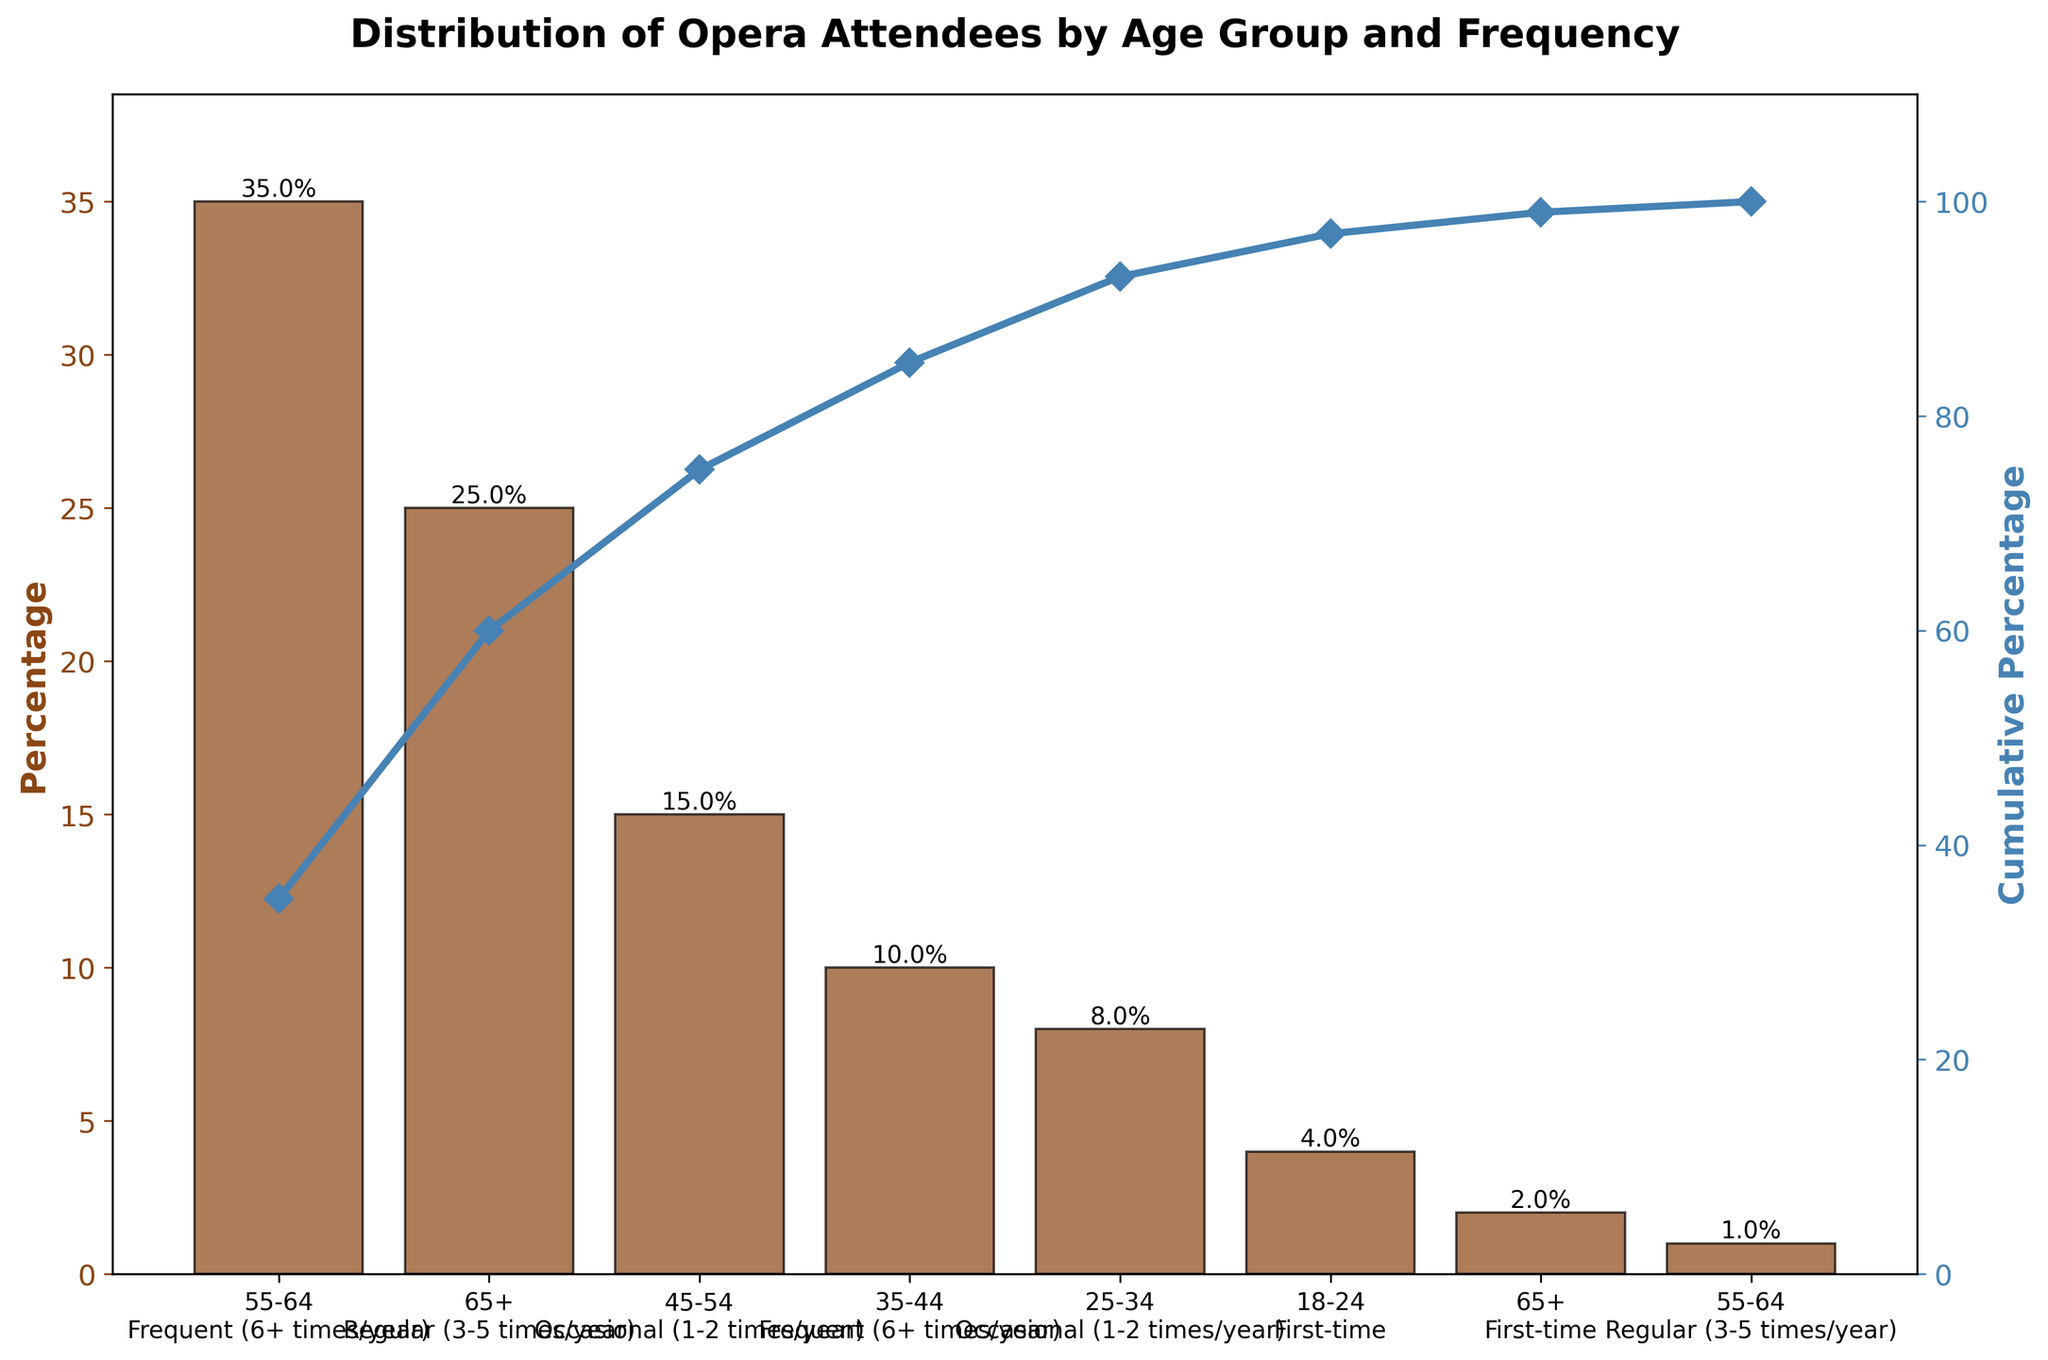What is the age group and frequency with the highest percentage of opera attendees? The figure indicates that the age group 55-64 who attend frequently (6+ times/year) has the highest percentage, as represented by the tallest bar on the chart.
Answer: 55-64, Frequent (6+ times/year) Which age group and frequency has the lowest percentage of opera attendees? The figure shows that the age group 55-64 who attend regularly (3-5 times/year) has the lowest percentage, represented by the shortest bar on the chart.
Answer: 55-64, Regular (3-5 times/year) What is the cumulative percentage after the second data point? The cumulative percentage is obtained by adding the percentages of the first two data points. The first one is 35% and the second one is 25%, so the cumulative percentage is 35% + 25% = 60%.
Answer: 60% How many age group and frequency combinations have a percentage higher than 20%? According to the chart, there are two combinations with a percentage higher than 20%. They are "55-64, Frequent (6+ times/year)" at 35% and "65+, Regular (3-5 times/year)" at 25%.
Answer: 2 Which age group and frequency combination contributes to 75% of the cumulative percentage? We need to add up the percentages until we reach or exceed 75%. From the chart, 55-64 Frequent (6+ times/year) = 35%, plus 65+ Regular (3-5 times/year) = 25% gives us 60%, and adding 45-54 Occasional (1-2 times/year) = 15% gives a total of 75%. So, up until the third combination, we reach 75%.
Answer: 45-54, Occasional (1-2 times/year) How does the cumulative percentage trend change after adding the age group 35-44 who attend frequently? The cumulative percentage after the third data point is 60%, after the fourth data point, which is 35-44 Frequent (6+ times/year), it becomes 60% + 10% = 70%. The rate of increase in the cumulative percentage slows down.
Answer: Slows down after 60% Which age group and frequency combination has the smallest deviation from 10%? Observing the percentages, the age group 35-44 Frequent (6+ times/year) is exactly 10%, making it the closest to 10%.
Answer: 35-44, Frequent (6+ times/year) What’s the total percentage represented by the first four combinations in the Pareto chart? Sum the percentages of the first four data points: 35% + 25% + 15% + 10% = 85%.
Answer: 85% Which age group and frequency has the closest cumulative percentage just under or equal to 90%? Adding the percentages, the cumulative percentage reaches 85% after four combinations. After adding the fifth combination, it becomes 93%, making the third combination the closest under 90%.
Answer: 45-54, Occasional (1-2 times/year) What is the cumulative percentage for the last three data points in the chart? The percentages for the last three points are 8%, 4%, and 2%. So adding them up gives 8% + 4% + 2% = 14%.
Answer: 14% 